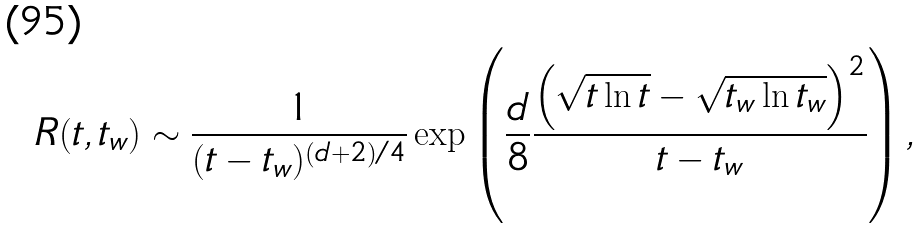Convert formula to latex. <formula><loc_0><loc_0><loc_500><loc_500>R ( t , t _ { w } ) \sim \frac { 1 } { ( t - t _ { w } ) ^ { ( d + 2 ) / 4 } } \exp \left ( \frac { d } { 8 } \frac { \left ( \sqrt { t \ln t } - \sqrt { t _ { w } \ln t _ { w } } \right ) ^ { 2 } } { t - t _ { w } } \right ) ,</formula> 